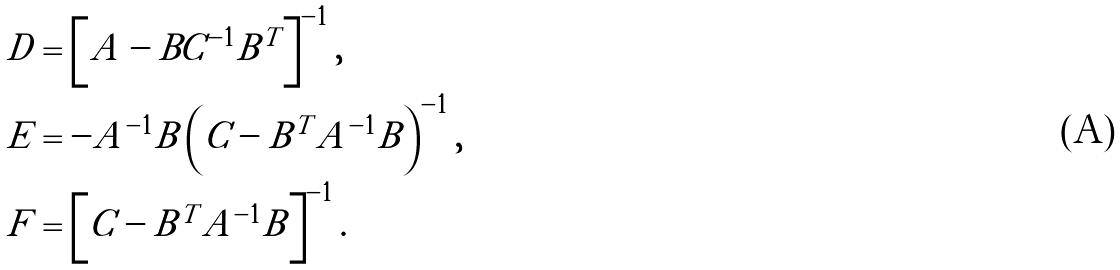<formula> <loc_0><loc_0><loc_500><loc_500>D & = \left [ A - B C ^ { - 1 } B ^ { T } \right ] ^ { - 1 } , \\ E & = - A ^ { - 1 } B \left ( C - B ^ { T } A ^ { - 1 } B \right ) ^ { - 1 } , \\ F & = \left [ C - B ^ { T } A ^ { - 1 } B \right ] ^ { - 1 } .</formula> 